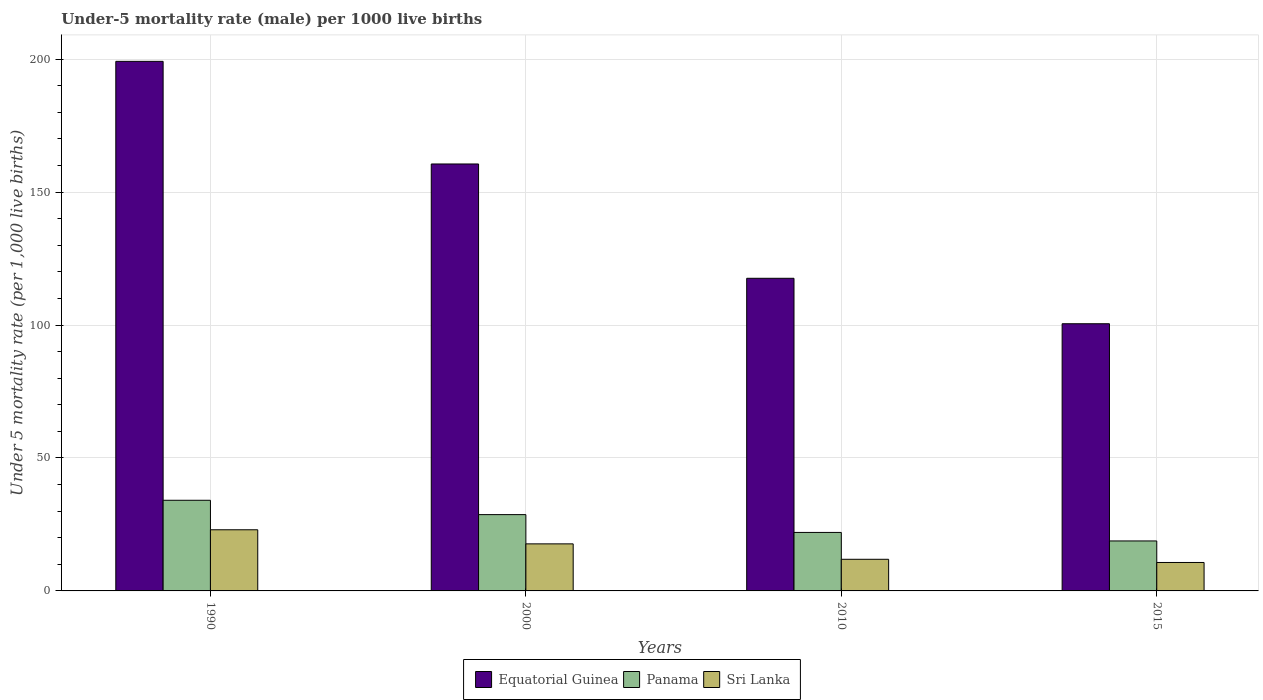How many different coloured bars are there?
Make the answer very short. 3. How many bars are there on the 3rd tick from the left?
Offer a very short reply. 3. What is the under-five mortality rate in Equatorial Guinea in 1990?
Offer a very short reply. 199.2. Across all years, what is the maximum under-five mortality rate in Equatorial Guinea?
Provide a short and direct response. 199.2. Across all years, what is the minimum under-five mortality rate in Equatorial Guinea?
Give a very brief answer. 100.5. In which year was the under-five mortality rate in Equatorial Guinea minimum?
Your answer should be very brief. 2015. What is the total under-five mortality rate in Equatorial Guinea in the graph?
Offer a very short reply. 577.9. What is the difference between the under-five mortality rate in Panama in 1990 and that in 2015?
Offer a terse response. 15.3. What is the average under-five mortality rate in Sri Lanka per year?
Provide a succinct answer. 15.82. In the year 1990, what is the difference between the under-five mortality rate in Equatorial Guinea and under-five mortality rate in Sri Lanka?
Your answer should be compact. 176.2. What is the ratio of the under-five mortality rate in Sri Lanka in 2000 to that in 2015?
Your answer should be compact. 1.65. What is the difference between the highest and the second highest under-five mortality rate in Sri Lanka?
Your answer should be compact. 5.3. What is the difference between the highest and the lowest under-five mortality rate in Sri Lanka?
Provide a short and direct response. 12.3. In how many years, is the under-five mortality rate in Panama greater than the average under-five mortality rate in Panama taken over all years?
Your response must be concise. 2. Is the sum of the under-five mortality rate in Equatorial Guinea in 1990 and 2010 greater than the maximum under-five mortality rate in Sri Lanka across all years?
Give a very brief answer. Yes. What does the 2nd bar from the left in 2010 represents?
Keep it short and to the point. Panama. What does the 2nd bar from the right in 2010 represents?
Your answer should be very brief. Panama. Is it the case that in every year, the sum of the under-five mortality rate in Sri Lanka and under-five mortality rate in Equatorial Guinea is greater than the under-five mortality rate in Panama?
Keep it short and to the point. Yes. Where does the legend appear in the graph?
Give a very brief answer. Bottom center. What is the title of the graph?
Offer a terse response. Under-5 mortality rate (male) per 1000 live births. Does "Latin America(all income levels)" appear as one of the legend labels in the graph?
Give a very brief answer. No. What is the label or title of the X-axis?
Your response must be concise. Years. What is the label or title of the Y-axis?
Keep it short and to the point. Under 5 mortality rate (per 1,0 live births). What is the Under 5 mortality rate (per 1,000 live births) of Equatorial Guinea in 1990?
Your response must be concise. 199.2. What is the Under 5 mortality rate (per 1,000 live births) of Panama in 1990?
Ensure brevity in your answer.  34.1. What is the Under 5 mortality rate (per 1,000 live births) in Sri Lanka in 1990?
Make the answer very short. 23. What is the Under 5 mortality rate (per 1,000 live births) of Equatorial Guinea in 2000?
Keep it short and to the point. 160.6. What is the Under 5 mortality rate (per 1,000 live births) in Panama in 2000?
Your answer should be very brief. 28.7. What is the Under 5 mortality rate (per 1,000 live births) of Sri Lanka in 2000?
Offer a very short reply. 17.7. What is the Under 5 mortality rate (per 1,000 live births) in Equatorial Guinea in 2010?
Provide a short and direct response. 117.6. What is the Under 5 mortality rate (per 1,000 live births) in Panama in 2010?
Ensure brevity in your answer.  22. What is the Under 5 mortality rate (per 1,000 live births) in Sri Lanka in 2010?
Provide a short and direct response. 11.9. What is the Under 5 mortality rate (per 1,000 live births) in Equatorial Guinea in 2015?
Your response must be concise. 100.5. Across all years, what is the maximum Under 5 mortality rate (per 1,000 live births) of Equatorial Guinea?
Make the answer very short. 199.2. Across all years, what is the maximum Under 5 mortality rate (per 1,000 live births) of Panama?
Keep it short and to the point. 34.1. Across all years, what is the maximum Under 5 mortality rate (per 1,000 live births) of Sri Lanka?
Keep it short and to the point. 23. Across all years, what is the minimum Under 5 mortality rate (per 1,000 live births) in Equatorial Guinea?
Your answer should be very brief. 100.5. Across all years, what is the minimum Under 5 mortality rate (per 1,000 live births) of Panama?
Provide a short and direct response. 18.8. What is the total Under 5 mortality rate (per 1,000 live births) in Equatorial Guinea in the graph?
Your answer should be very brief. 577.9. What is the total Under 5 mortality rate (per 1,000 live births) in Panama in the graph?
Offer a terse response. 103.6. What is the total Under 5 mortality rate (per 1,000 live births) of Sri Lanka in the graph?
Offer a terse response. 63.3. What is the difference between the Under 5 mortality rate (per 1,000 live births) in Equatorial Guinea in 1990 and that in 2000?
Offer a terse response. 38.6. What is the difference between the Under 5 mortality rate (per 1,000 live births) in Panama in 1990 and that in 2000?
Offer a very short reply. 5.4. What is the difference between the Under 5 mortality rate (per 1,000 live births) of Sri Lanka in 1990 and that in 2000?
Ensure brevity in your answer.  5.3. What is the difference between the Under 5 mortality rate (per 1,000 live births) in Equatorial Guinea in 1990 and that in 2010?
Keep it short and to the point. 81.6. What is the difference between the Under 5 mortality rate (per 1,000 live births) of Panama in 1990 and that in 2010?
Your response must be concise. 12.1. What is the difference between the Under 5 mortality rate (per 1,000 live births) in Equatorial Guinea in 1990 and that in 2015?
Your answer should be very brief. 98.7. What is the difference between the Under 5 mortality rate (per 1,000 live births) of Sri Lanka in 1990 and that in 2015?
Provide a short and direct response. 12.3. What is the difference between the Under 5 mortality rate (per 1,000 live births) in Equatorial Guinea in 2000 and that in 2010?
Provide a succinct answer. 43. What is the difference between the Under 5 mortality rate (per 1,000 live births) of Panama in 2000 and that in 2010?
Your answer should be very brief. 6.7. What is the difference between the Under 5 mortality rate (per 1,000 live births) in Equatorial Guinea in 2000 and that in 2015?
Provide a short and direct response. 60.1. What is the difference between the Under 5 mortality rate (per 1,000 live births) in Panama in 2000 and that in 2015?
Ensure brevity in your answer.  9.9. What is the difference between the Under 5 mortality rate (per 1,000 live births) in Equatorial Guinea in 2010 and that in 2015?
Offer a terse response. 17.1. What is the difference between the Under 5 mortality rate (per 1,000 live births) of Panama in 2010 and that in 2015?
Your answer should be compact. 3.2. What is the difference between the Under 5 mortality rate (per 1,000 live births) in Sri Lanka in 2010 and that in 2015?
Keep it short and to the point. 1.2. What is the difference between the Under 5 mortality rate (per 1,000 live births) of Equatorial Guinea in 1990 and the Under 5 mortality rate (per 1,000 live births) of Panama in 2000?
Your answer should be very brief. 170.5. What is the difference between the Under 5 mortality rate (per 1,000 live births) of Equatorial Guinea in 1990 and the Under 5 mortality rate (per 1,000 live births) of Sri Lanka in 2000?
Keep it short and to the point. 181.5. What is the difference between the Under 5 mortality rate (per 1,000 live births) in Equatorial Guinea in 1990 and the Under 5 mortality rate (per 1,000 live births) in Panama in 2010?
Provide a short and direct response. 177.2. What is the difference between the Under 5 mortality rate (per 1,000 live births) in Equatorial Guinea in 1990 and the Under 5 mortality rate (per 1,000 live births) in Sri Lanka in 2010?
Your answer should be very brief. 187.3. What is the difference between the Under 5 mortality rate (per 1,000 live births) of Panama in 1990 and the Under 5 mortality rate (per 1,000 live births) of Sri Lanka in 2010?
Keep it short and to the point. 22.2. What is the difference between the Under 5 mortality rate (per 1,000 live births) in Equatorial Guinea in 1990 and the Under 5 mortality rate (per 1,000 live births) in Panama in 2015?
Provide a short and direct response. 180.4. What is the difference between the Under 5 mortality rate (per 1,000 live births) of Equatorial Guinea in 1990 and the Under 5 mortality rate (per 1,000 live births) of Sri Lanka in 2015?
Your response must be concise. 188.5. What is the difference between the Under 5 mortality rate (per 1,000 live births) of Panama in 1990 and the Under 5 mortality rate (per 1,000 live births) of Sri Lanka in 2015?
Ensure brevity in your answer.  23.4. What is the difference between the Under 5 mortality rate (per 1,000 live births) of Equatorial Guinea in 2000 and the Under 5 mortality rate (per 1,000 live births) of Panama in 2010?
Offer a terse response. 138.6. What is the difference between the Under 5 mortality rate (per 1,000 live births) of Equatorial Guinea in 2000 and the Under 5 mortality rate (per 1,000 live births) of Sri Lanka in 2010?
Make the answer very short. 148.7. What is the difference between the Under 5 mortality rate (per 1,000 live births) of Equatorial Guinea in 2000 and the Under 5 mortality rate (per 1,000 live births) of Panama in 2015?
Give a very brief answer. 141.8. What is the difference between the Under 5 mortality rate (per 1,000 live births) in Equatorial Guinea in 2000 and the Under 5 mortality rate (per 1,000 live births) in Sri Lanka in 2015?
Your response must be concise. 149.9. What is the difference between the Under 5 mortality rate (per 1,000 live births) of Equatorial Guinea in 2010 and the Under 5 mortality rate (per 1,000 live births) of Panama in 2015?
Offer a very short reply. 98.8. What is the difference between the Under 5 mortality rate (per 1,000 live births) of Equatorial Guinea in 2010 and the Under 5 mortality rate (per 1,000 live births) of Sri Lanka in 2015?
Your response must be concise. 106.9. What is the average Under 5 mortality rate (per 1,000 live births) of Equatorial Guinea per year?
Keep it short and to the point. 144.47. What is the average Under 5 mortality rate (per 1,000 live births) of Panama per year?
Your response must be concise. 25.9. What is the average Under 5 mortality rate (per 1,000 live births) of Sri Lanka per year?
Give a very brief answer. 15.82. In the year 1990, what is the difference between the Under 5 mortality rate (per 1,000 live births) in Equatorial Guinea and Under 5 mortality rate (per 1,000 live births) in Panama?
Keep it short and to the point. 165.1. In the year 1990, what is the difference between the Under 5 mortality rate (per 1,000 live births) in Equatorial Guinea and Under 5 mortality rate (per 1,000 live births) in Sri Lanka?
Ensure brevity in your answer.  176.2. In the year 1990, what is the difference between the Under 5 mortality rate (per 1,000 live births) in Panama and Under 5 mortality rate (per 1,000 live births) in Sri Lanka?
Your response must be concise. 11.1. In the year 2000, what is the difference between the Under 5 mortality rate (per 1,000 live births) in Equatorial Guinea and Under 5 mortality rate (per 1,000 live births) in Panama?
Make the answer very short. 131.9. In the year 2000, what is the difference between the Under 5 mortality rate (per 1,000 live births) in Equatorial Guinea and Under 5 mortality rate (per 1,000 live births) in Sri Lanka?
Offer a terse response. 142.9. In the year 2000, what is the difference between the Under 5 mortality rate (per 1,000 live births) of Panama and Under 5 mortality rate (per 1,000 live births) of Sri Lanka?
Provide a succinct answer. 11. In the year 2010, what is the difference between the Under 5 mortality rate (per 1,000 live births) of Equatorial Guinea and Under 5 mortality rate (per 1,000 live births) of Panama?
Your answer should be very brief. 95.6. In the year 2010, what is the difference between the Under 5 mortality rate (per 1,000 live births) of Equatorial Guinea and Under 5 mortality rate (per 1,000 live births) of Sri Lanka?
Your response must be concise. 105.7. In the year 2010, what is the difference between the Under 5 mortality rate (per 1,000 live births) in Panama and Under 5 mortality rate (per 1,000 live births) in Sri Lanka?
Keep it short and to the point. 10.1. In the year 2015, what is the difference between the Under 5 mortality rate (per 1,000 live births) of Equatorial Guinea and Under 5 mortality rate (per 1,000 live births) of Panama?
Keep it short and to the point. 81.7. In the year 2015, what is the difference between the Under 5 mortality rate (per 1,000 live births) in Equatorial Guinea and Under 5 mortality rate (per 1,000 live births) in Sri Lanka?
Your answer should be compact. 89.8. What is the ratio of the Under 5 mortality rate (per 1,000 live births) of Equatorial Guinea in 1990 to that in 2000?
Offer a terse response. 1.24. What is the ratio of the Under 5 mortality rate (per 1,000 live births) in Panama in 1990 to that in 2000?
Your response must be concise. 1.19. What is the ratio of the Under 5 mortality rate (per 1,000 live births) of Sri Lanka in 1990 to that in 2000?
Provide a succinct answer. 1.3. What is the ratio of the Under 5 mortality rate (per 1,000 live births) in Equatorial Guinea in 1990 to that in 2010?
Ensure brevity in your answer.  1.69. What is the ratio of the Under 5 mortality rate (per 1,000 live births) in Panama in 1990 to that in 2010?
Make the answer very short. 1.55. What is the ratio of the Under 5 mortality rate (per 1,000 live births) of Sri Lanka in 1990 to that in 2010?
Your response must be concise. 1.93. What is the ratio of the Under 5 mortality rate (per 1,000 live births) of Equatorial Guinea in 1990 to that in 2015?
Make the answer very short. 1.98. What is the ratio of the Under 5 mortality rate (per 1,000 live births) in Panama in 1990 to that in 2015?
Provide a succinct answer. 1.81. What is the ratio of the Under 5 mortality rate (per 1,000 live births) of Sri Lanka in 1990 to that in 2015?
Your response must be concise. 2.15. What is the ratio of the Under 5 mortality rate (per 1,000 live births) in Equatorial Guinea in 2000 to that in 2010?
Offer a very short reply. 1.37. What is the ratio of the Under 5 mortality rate (per 1,000 live births) of Panama in 2000 to that in 2010?
Keep it short and to the point. 1.3. What is the ratio of the Under 5 mortality rate (per 1,000 live births) of Sri Lanka in 2000 to that in 2010?
Offer a terse response. 1.49. What is the ratio of the Under 5 mortality rate (per 1,000 live births) in Equatorial Guinea in 2000 to that in 2015?
Your answer should be very brief. 1.6. What is the ratio of the Under 5 mortality rate (per 1,000 live births) in Panama in 2000 to that in 2015?
Make the answer very short. 1.53. What is the ratio of the Under 5 mortality rate (per 1,000 live births) of Sri Lanka in 2000 to that in 2015?
Ensure brevity in your answer.  1.65. What is the ratio of the Under 5 mortality rate (per 1,000 live births) of Equatorial Guinea in 2010 to that in 2015?
Make the answer very short. 1.17. What is the ratio of the Under 5 mortality rate (per 1,000 live births) of Panama in 2010 to that in 2015?
Your answer should be compact. 1.17. What is the ratio of the Under 5 mortality rate (per 1,000 live births) in Sri Lanka in 2010 to that in 2015?
Your answer should be very brief. 1.11. What is the difference between the highest and the second highest Under 5 mortality rate (per 1,000 live births) in Equatorial Guinea?
Offer a very short reply. 38.6. What is the difference between the highest and the second highest Under 5 mortality rate (per 1,000 live births) in Sri Lanka?
Make the answer very short. 5.3. What is the difference between the highest and the lowest Under 5 mortality rate (per 1,000 live births) in Equatorial Guinea?
Provide a short and direct response. 98.7. What is the difference between the highest and the lowest Under 5 mortality rate (per 1,000 live births) of Sri Lanka?
Give a very brief answer. 12.3. 